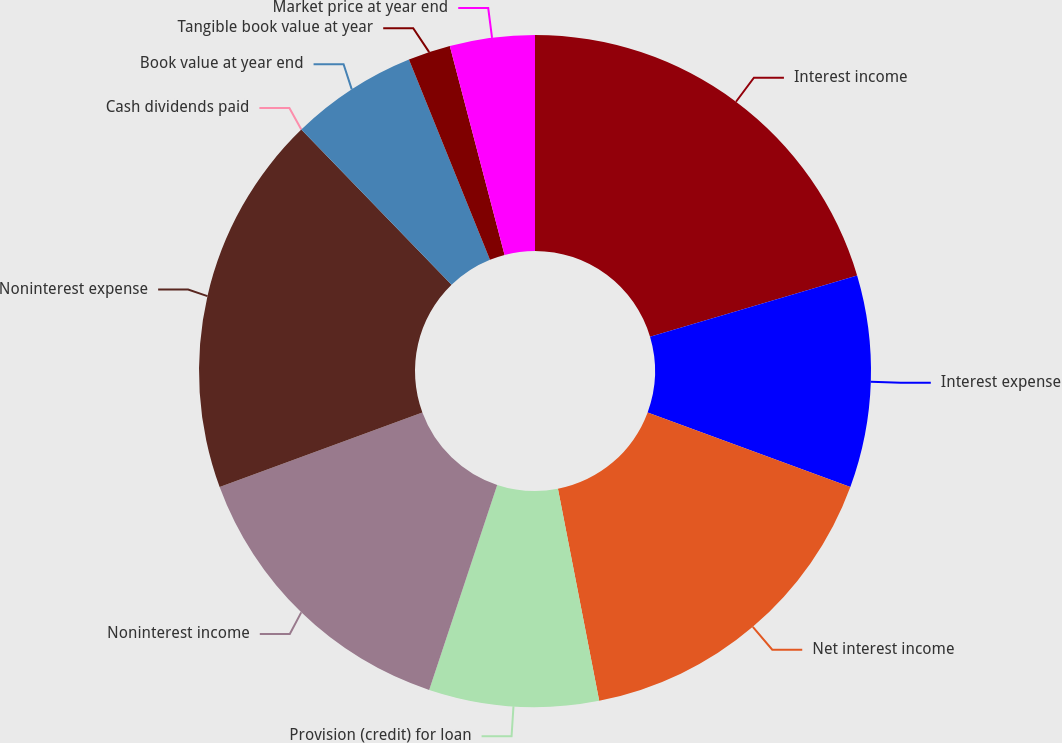Convert chart. <chart><loc_0><loc_0><loc_500><loc_500><pie_chart><fcel>Interest income<fcel>Interest expense<fcel>Net interest income<fcel>Provision (credit) for loan<fcel>Noninterest income<fcel>Noninterest expense<fcel>Cash dividends paid<fcel>Book value at year end<fcel>Tangible book value at year<fcel>Market price at year end<nl><fcel>20.41%<fcel>10.2%<fcel>16.33%<fcel>8.16%<fcel>14.29%<fcel>18.37%<fcel>0.0%<fcel>6.12%<fcel>2.04%<fcel>4.08%<nl></chart> 